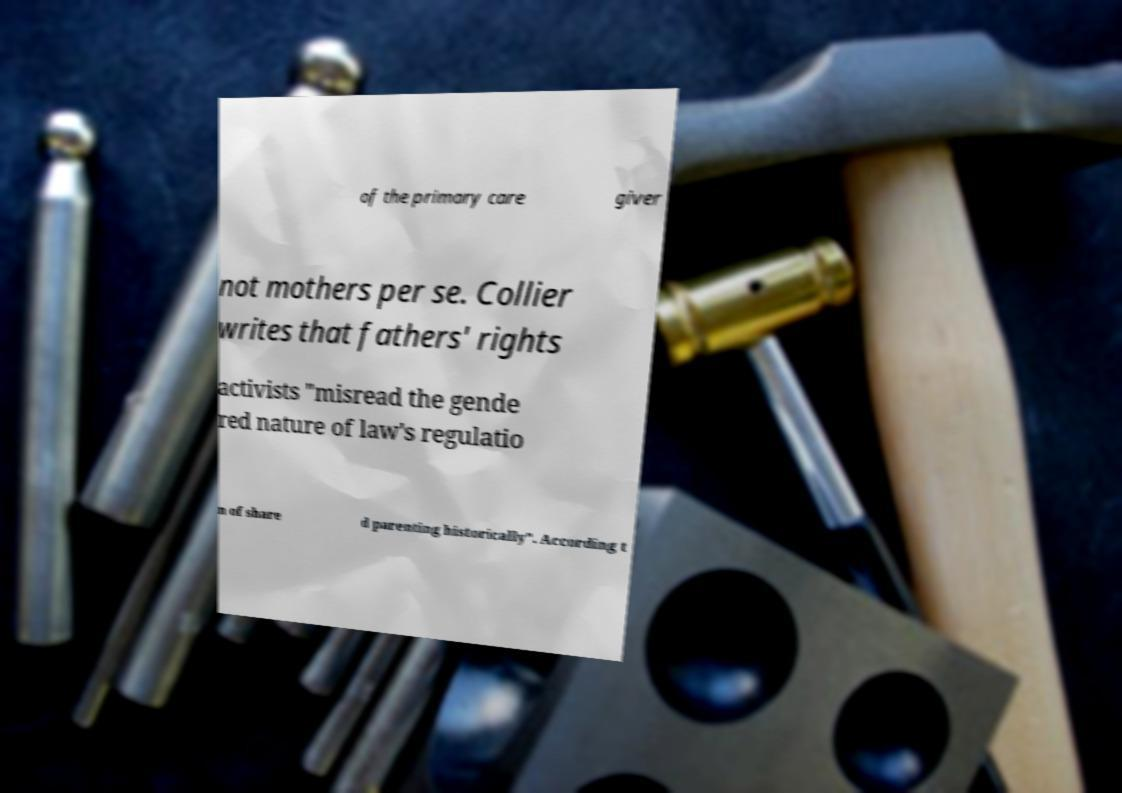Could you assist in decoding the text presented in this image and type it out clearly? of the primary care giver not mothers per se. Collier writes that fathers' rights activists "misread the gende red nature of law's regulatio n of share d parenting historically". According t 